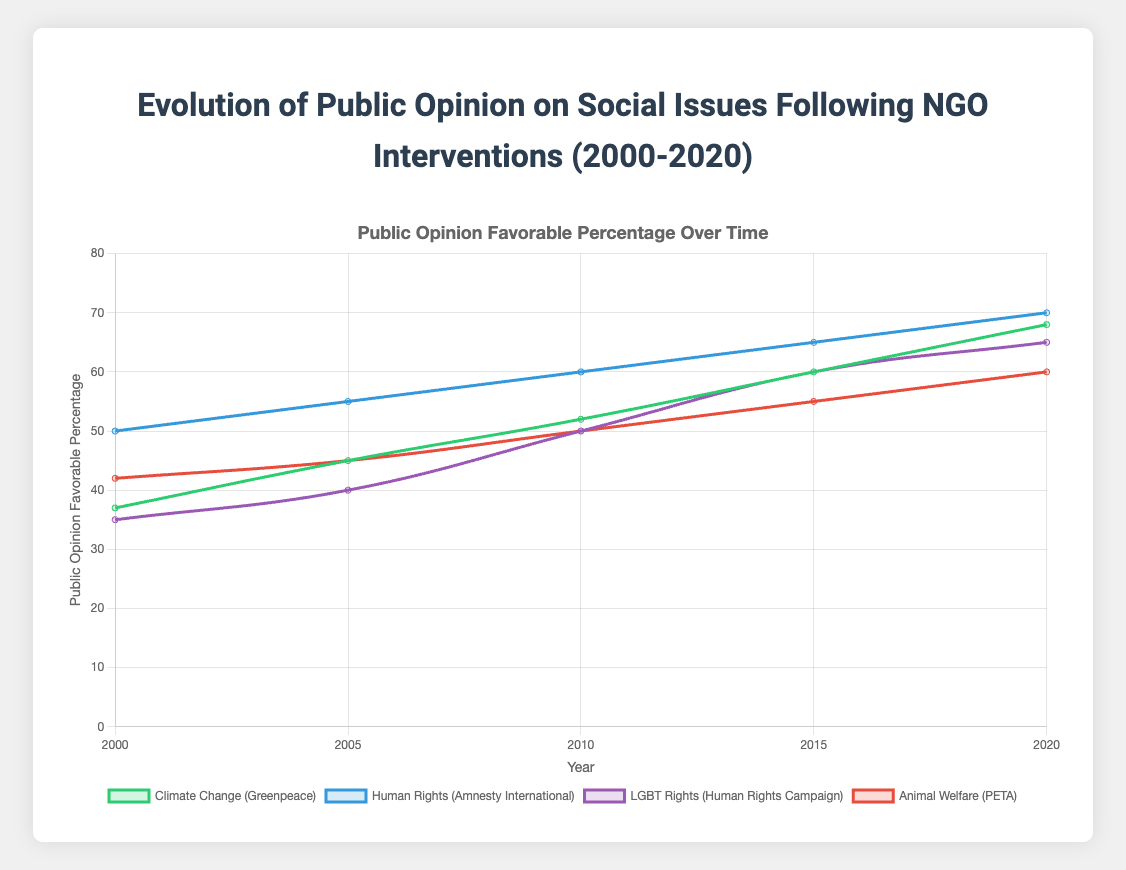Which social issue had the highest favorable public opinion percentage in 2020? Review the figure and compare the data points for all issues in 2020. Human Rights has the highest favorable percentage at 70%.
Answer: Human Rights How much did the public opinion on Climate Change improve from 2000 to 2020? To find the increase, subtract the 2000 value from the 2020 value: 68 - 37 = 31.
Answer: 31 Compare the public opinion trends of Human Rights and LGBT Rights between 2000 and 2020. Which showed a greater overall increase? Calculate the difference for both issues from 2000 to 2020. Human Rights increased from 50 to 70 (20 points), and LGBT Rights from 35 to 65 (30 points). LGBT Rights showed a greater increase.
Answer: LGBT Rights What's the average favorable public opinion percentage for PETA (Animal Welfare) over the years shown? Add up the percentages for all five years and divide by 5: (42 + 45 + 50 + 55 + 60) / 5 = 252 / 5 = 50.4.
Answer: 50.4 Which NGO had the least change in public opinion from 2000 to 2020? Calculate the difference for each NGO from 2000 to 2020 and find the smallest change. PETA (Animal Welfare): 60 - 42 = 18; least change.
Answer: PETA In which year did public opinion on LGBT Rights (Human Rights Campaign) surpass 50%? Find the year where the percentage exceeds 50%. In 2010, public opinion was exactly 50%, and it surpassed 50% by 2015.
Answer: 2015 Between 2005 and 2010, which social issue had the largest increase in favorable public opinion percentage? Calculate the increase for each issue in that period and identify the largest: Climate Change: 52 - 45 = 7; Human Rights: 60 - 55 = 5; LGBT Rights: 50 - 40 = 10; Animal Welfare: 50 - 45 = 5. LGBT Rights had the largest increase of 10 points.
Answer: LGBT Rights Which year did all the social issues have the closest favorable public opinion percentages? Compare the ranges of percentages for each year and determine the year with the smallest range. In 2010, percentages range from 50% to 60%, a range of 10 points.
Answer: 2010 What is the difference in public opinion between Animal Welfare (PETA) and Climate Change (Greenpeace) in 2020? Subtract the percentage of Animal Welfare from Climate Change in 2020: 68 - 60 = 8.
Answer: 8 Rank the social issues by their public opinion percentage in 2005, from highest to lowest. Compare the percentages in 2005. Rank: Human Rights (55), Climate Change (45), Animal Welfare (45), LGBT Rights (40).
Answer: Human Rights, Climate Change, Animal Welfare, LGBT Rights 